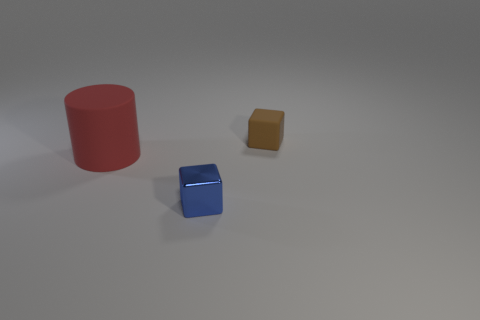Is there any other thing that is the same size as the red cylinder?
Keep it short and to the point. No. What is the color of the small matte object that is the same shape as the small shiny object?
Provide a succinct answer. Brown. How many matte things are on the right side of the big red rubber thing and left of the brown rubber cube?
Your answer should be compact. 0. Are there more matte cubes that are in front of the red object than tiny metal cubes left of the blue metal block?
Ensure brevity in your answer.  No. The brown block has what size?
Keep it short and to the point. Small. Is there another thing that has the same shape as the tiny metallic thing?
Ensure brevity in your answer.  Yes. Do the big rubber thing and the small thing that is behind the blue cube have the same shape?
Offer a terse response. No. What is the size of the thing that is right of the large red object and behind the blue cube?
Make the answer very short. Small. What number of small yellow cylinders are there?
Provide a short and direct response. 0. There is another cube that is the same size as the blue metallic cube; what is its material?
Ensure brevity in your answer.  Rubber. 